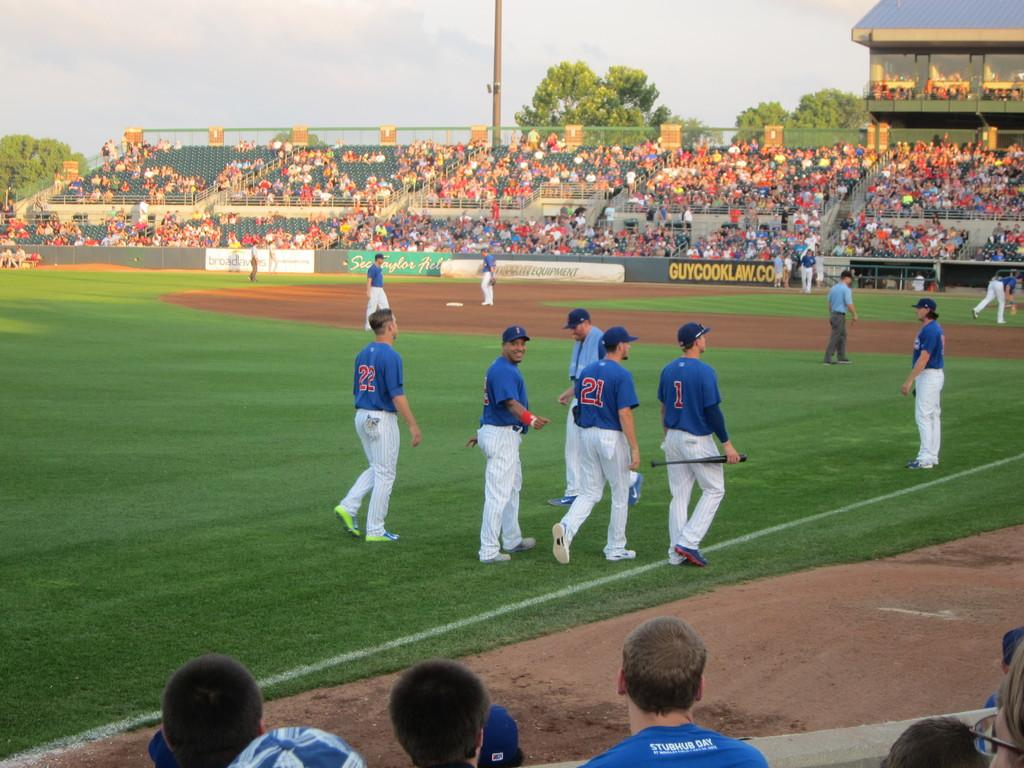<image>
Relay a brief, clear account of the picture shown. A young man wearing a blue shirt proclaiming it to be Stubhub day sits in the front row at a baseball game 